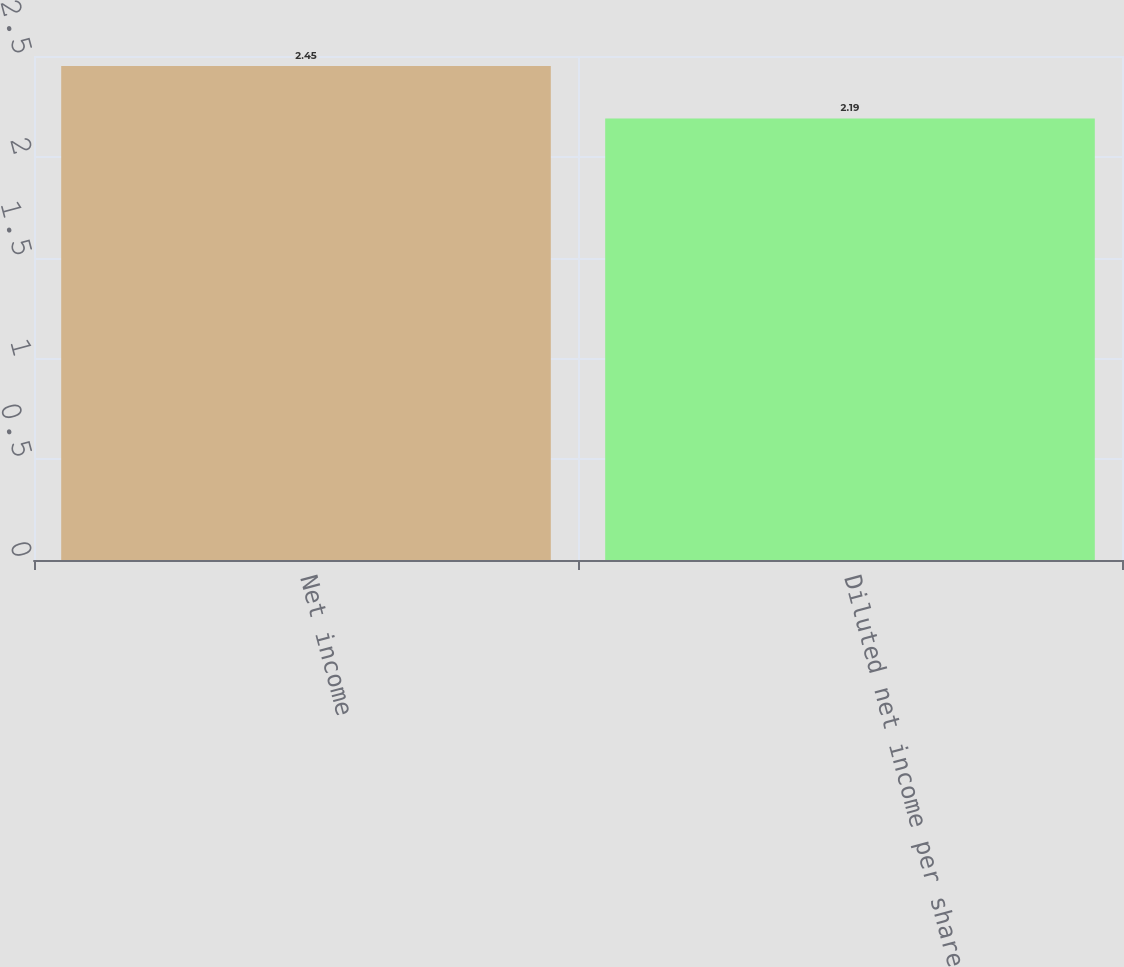Convert chart to OTSL. <chart><loc_0><loc_0><loc_500><loc_500><bar_chart><fcel>Net income<fcel>Diluted net income per share<nl><fcel>2.45<fcel>2.19<nl></chart> 